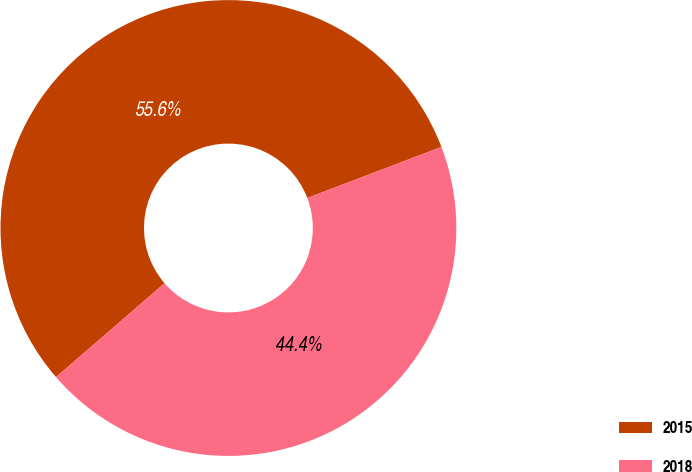<chart> <loc_0><loc_0><loc_500><loc_500><pie_chart><fcel>2015<fcel>2018<nl><fcel>55.56%<fcel>44.44%<nl></chart> 